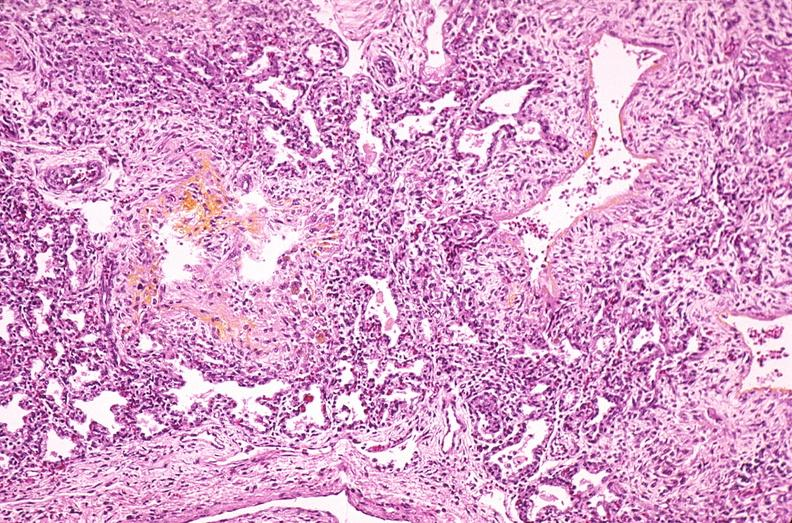where is this?
Answer the question using a single word or phrase. Lung 